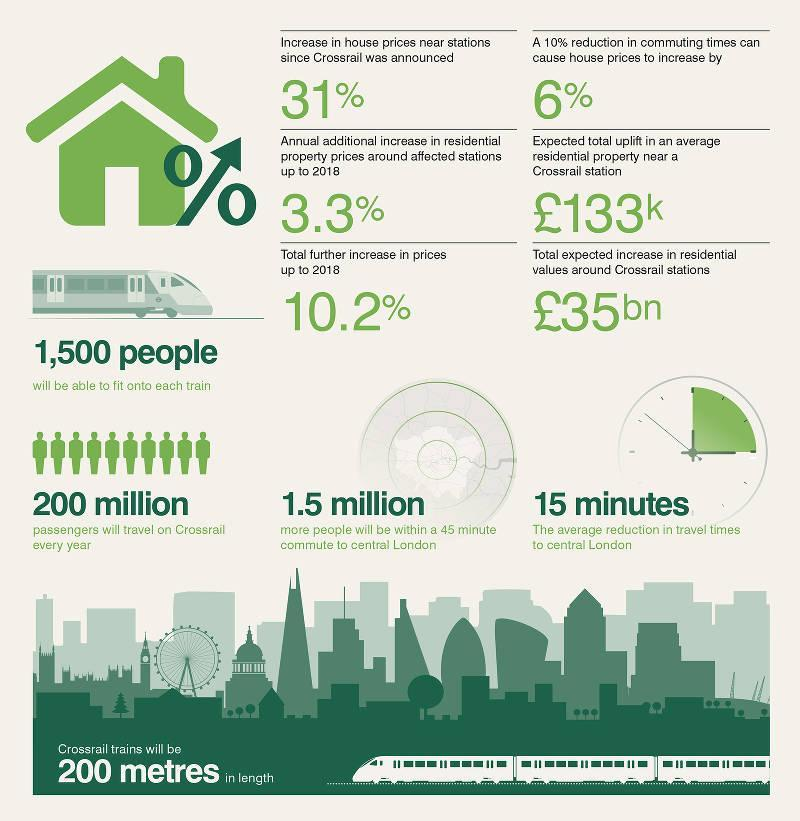By what percent did house prices go up due to decrease in commuting times?
Answer the question with a short phrase. 6% What was the additional increase in price of properties near stations till 2018? 3.3% By how much % did house prices increase since announcement of Crossrail? 31% What is the carrying capacity of each train? 1,500 people What was the total increase in house prices till 2018? 10.2% When the Crossrail is functional how many more people will be within a 45 minute commute to central London? 1.5 million How many passengers can travel every year on Crossrail? 200 million What will be the average reduction in travel times to central London? 15 minutes 